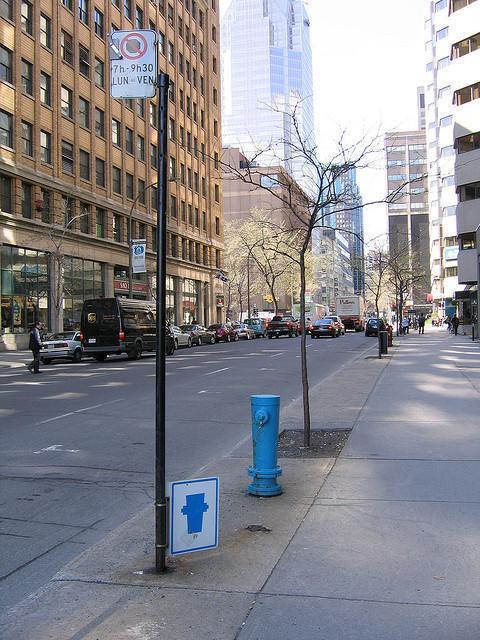How many fences shown in this picture are between the giraffe and the camera?
Give a very brief answer. 0. 